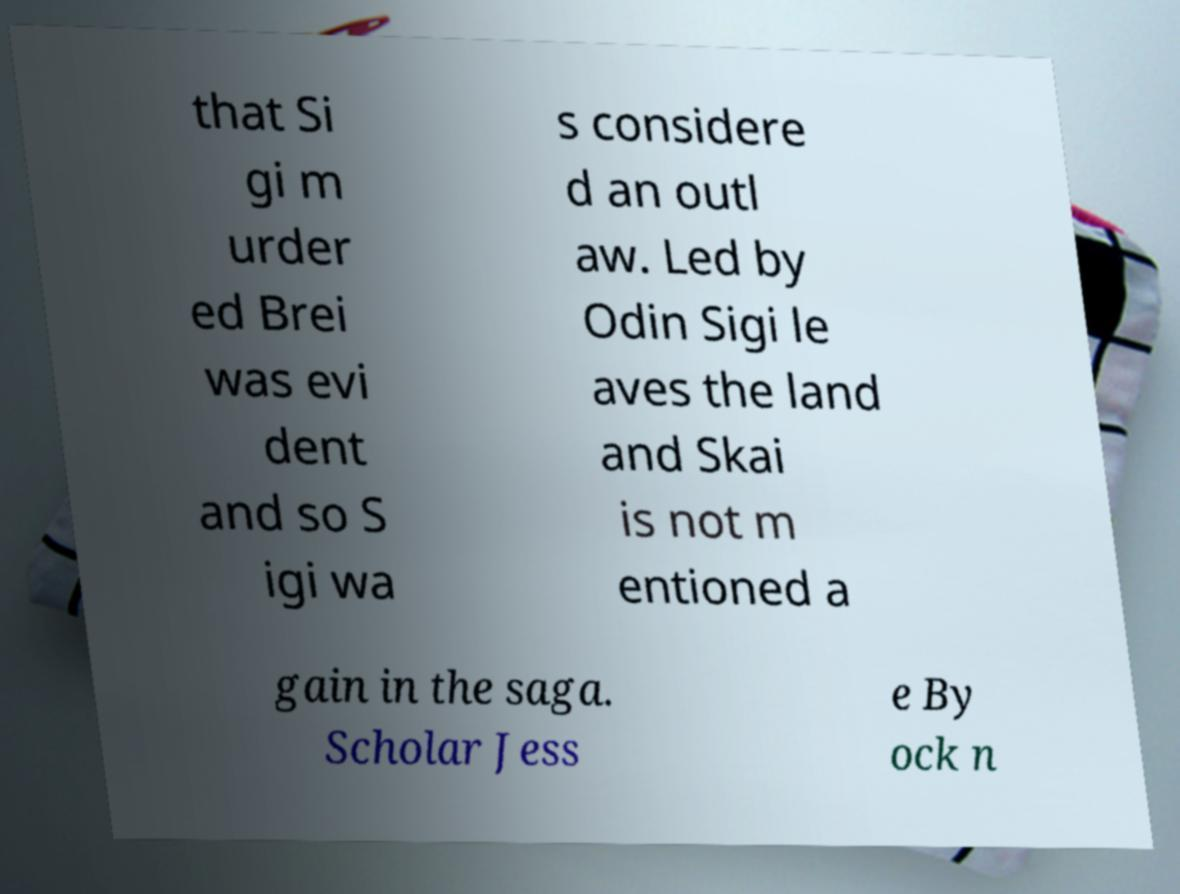For documentation purposes, I need the text within this image transcribed. Could you provide that? that Si gi m urder ed Brei was evi dent and so S igi wa s considere d an outl aw. Led by Odin Sigi le aves the land and Skai is not m entioned a gain in the saga. Scholar Jess e By ock n 